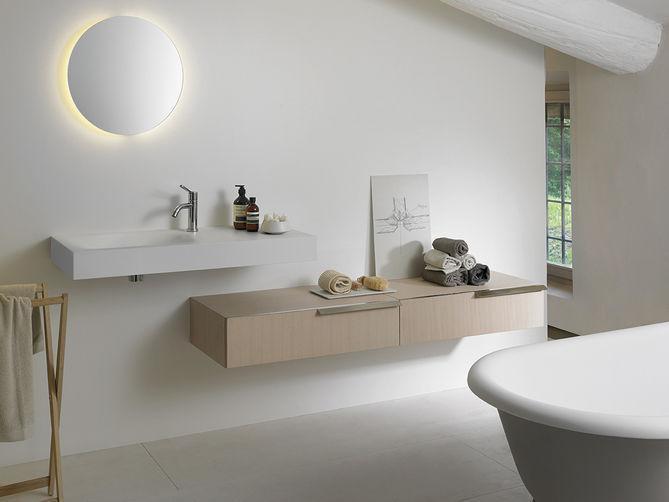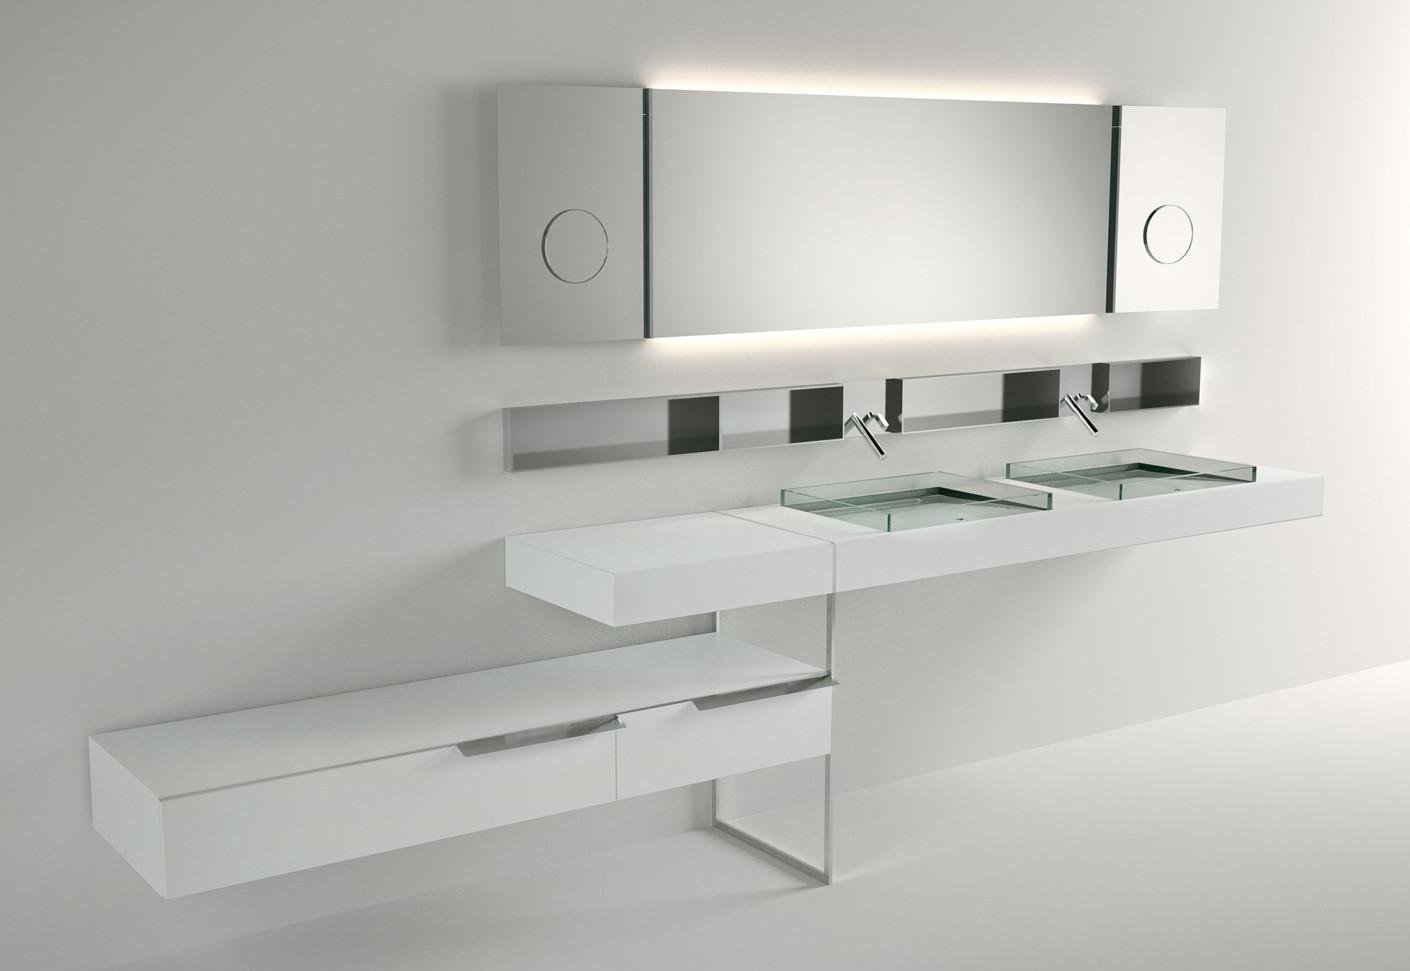The first image is the image on the left, the second image is the image on the right. Examine the images to the left and right. Is the description "One image shows a wall-mounted rectangular counter with two separate sink and faucet features." accurate? Answer yes or no. Yes. The first image is the image on the left, the second image is the image on the right. Evaluate the accuracy of this statement regarding the images: "There are two basins set in the counter on the right.". Is it true? Answer yes or no. Yes. 